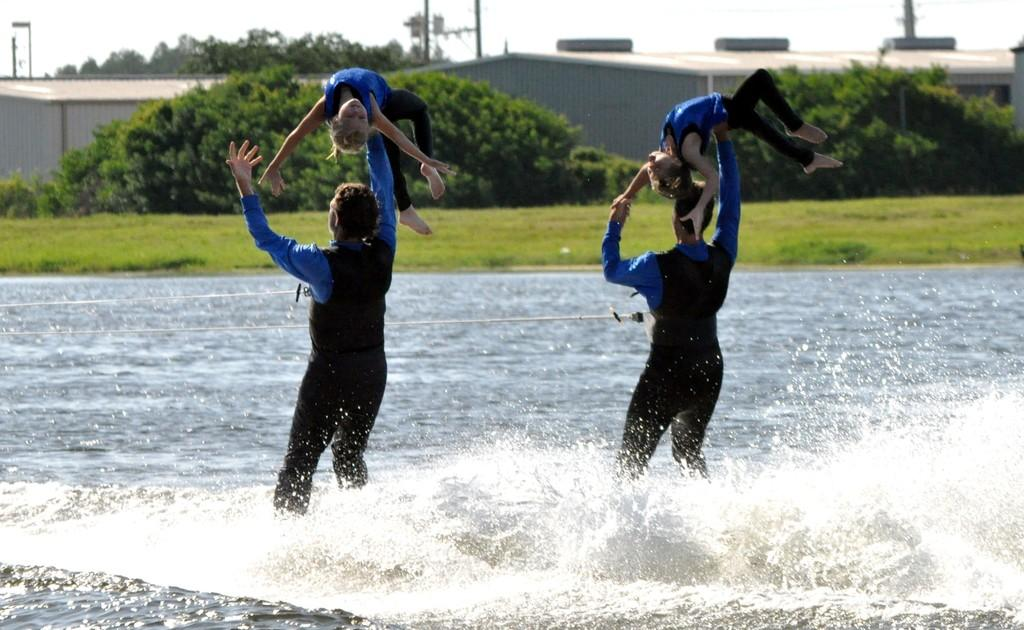What are the two persons in the image doing? The two persons are standing in the water and carrying kids. What can be seen in the background of the image? There are trees, grass, buildings, poles, and the sky visible in the background of the image. How many kids are being carried by the persons in the image? The image shows two persons carrying kids, but it is not clear how many kids are being carried in total. What type of suit is the thread being used to sew in the image? There is no suit or thread present in the image. What is the yarn being used for in the image? There is no yarn present in the image. 